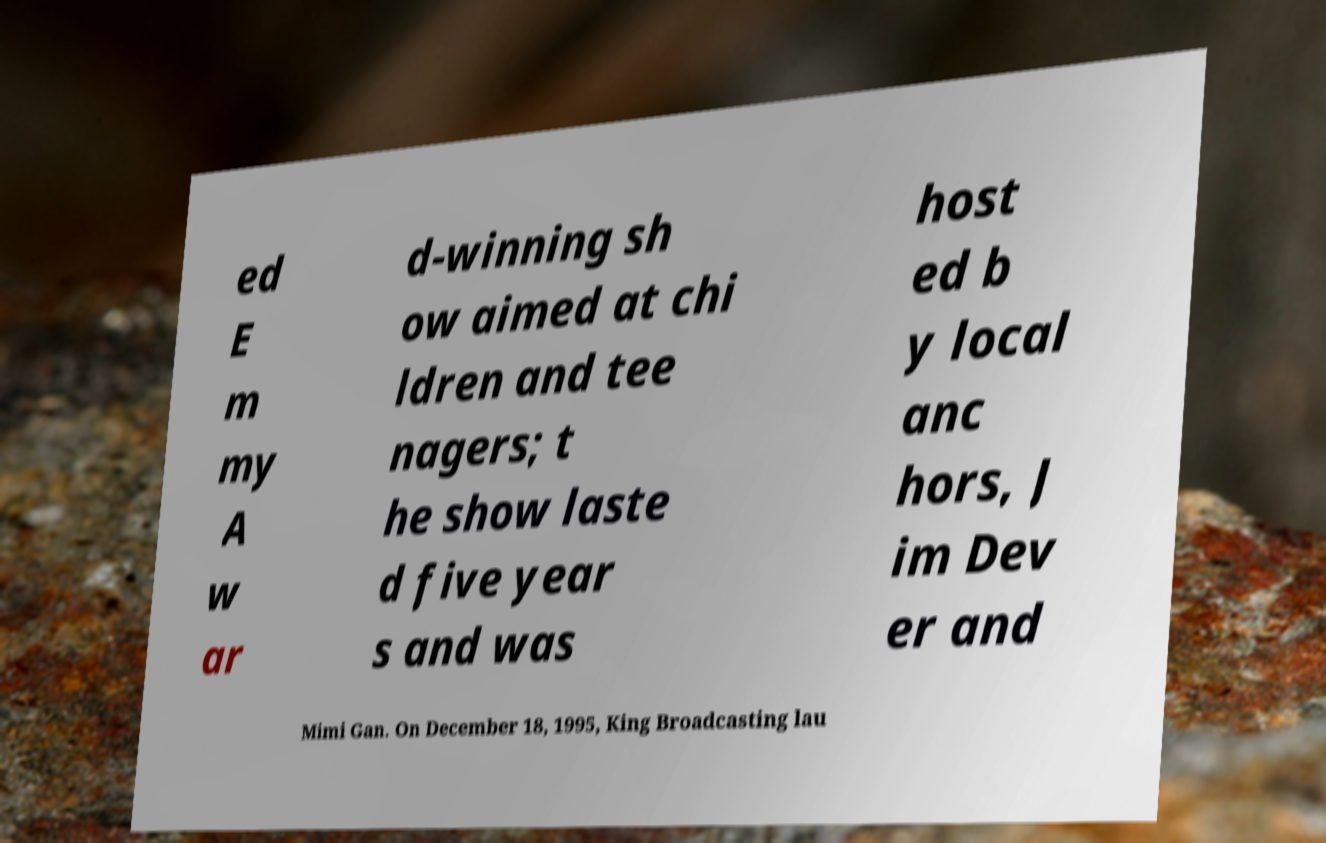Please read and relay the text visible in this image. What does it say? ed E m my A w ar d-winning sh ow aimed at chi ldren and tee nagers; t he show laste d five year s and was host ed b y local anc hors, J im Dev er and Mimi Gan. On December 18, 1995, King Broadcasting lau 